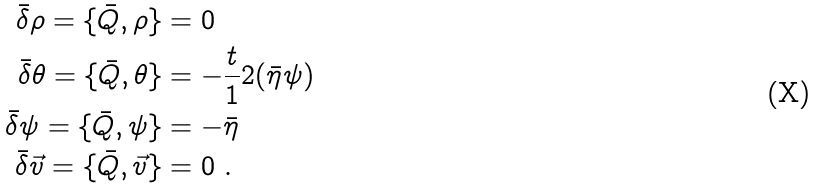Convert formula to latex. <formula><loc_0><loc_0><loc_500><loc_500>\bar { \delta } \rho = \{ \bar { Q } , \rho \} & = 0 \\ \bar { \delta } \theta = \{ \bar { Q } , \theta \} & = - \frac { t } { 1 } 2 ( \bar { \eta } \psi ) \\ \bar { \delta } \psi = \{ \bar { Q } , \psi \} & = - \bar { \eta } \\ \bar { \delta } \vec { v } = \{ \bar { Q } , \vec { v } \} & = 0 \ .</formula> 